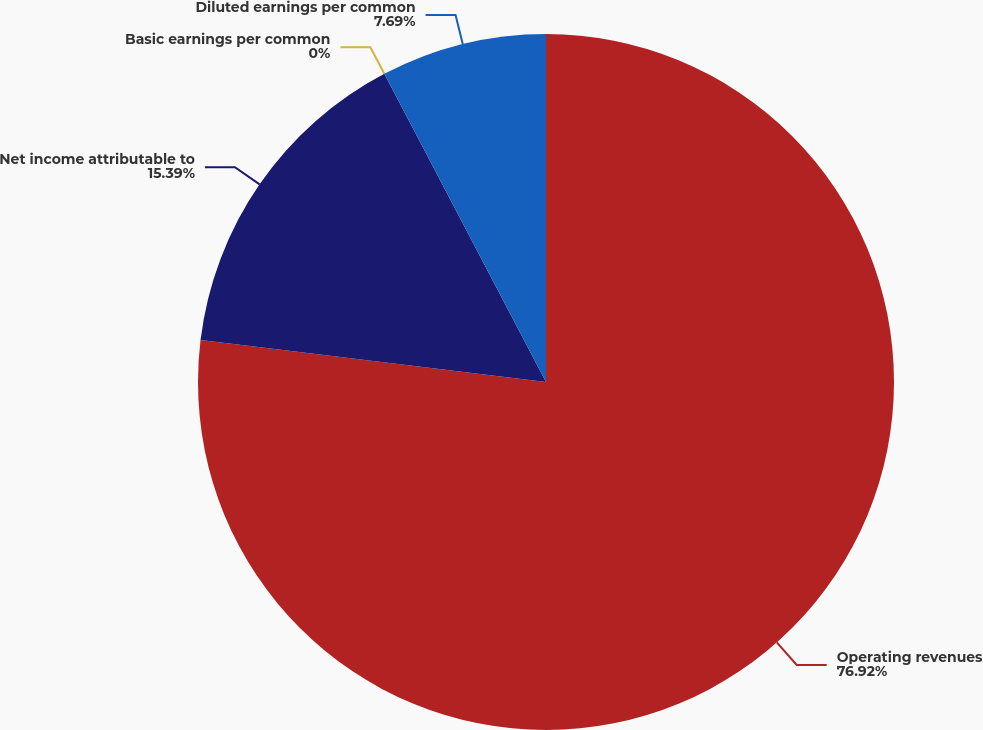Convert chart to OTSL. <chart><loc_0><loc_0><loc_500><loc_500><pie_chart><fcel>Operating revenues<fcel>Net income attributable to<fcel>Basic earnings per common<fcel>Diluted earnings per common<nl><fcel>76.92%<fcel>15.39%<fcel>0.0%<fcel>7.69%<nl></chart> 